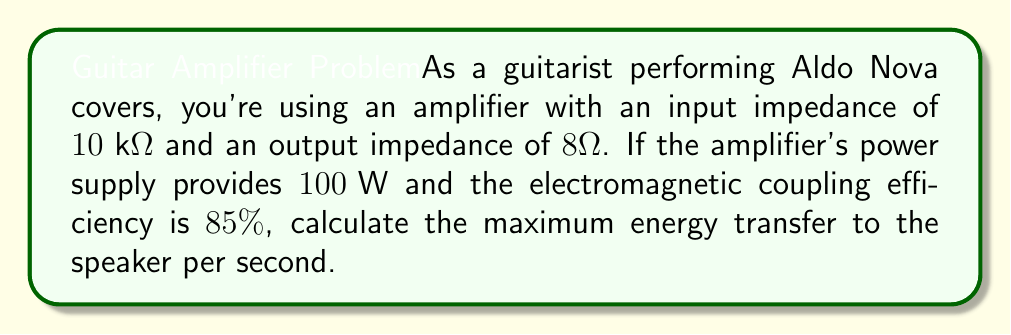Teach me how to tackle this problem. To solve this problem, we'll use the concept of maximum power transfer and electromagnetic coupling efficiency:

1) The maximum power transfer theorem states that maximum power is transferred when the load impedance matches the source impedance. However, in audio amplifiers, this isn't practical due to the large difference between input and output impedances.

2) Instead, we focus on the power supplied by the amplifier and the efficiency of energy transfer.

3) The power supply provides $100\text{ W}$ of power:

   $$P_{\text{supply}} = 100\text{ W}$$

4) The electromagnetic coupling efficiency is $85\%$ or $0.85$:

   $$\eta = 0.85$$

5) To calculate the energy transfer to the speaker per second, we multiply the supply power by the efficiency:

   $$E_{\text{transfer}} = P_{\text{supply}} \times \eta$$

6) Substituting the values:

   $$E_{\text{transfer}} = 100\text{ W} \times 0.85$$

7) Computing the result:

   $$E_{\text{transfer}} = 85\text{ J/s}$$

This means that 85 joules of energy are transferred to the speaker every second.
Answer: $85\text{ J/s}$ 